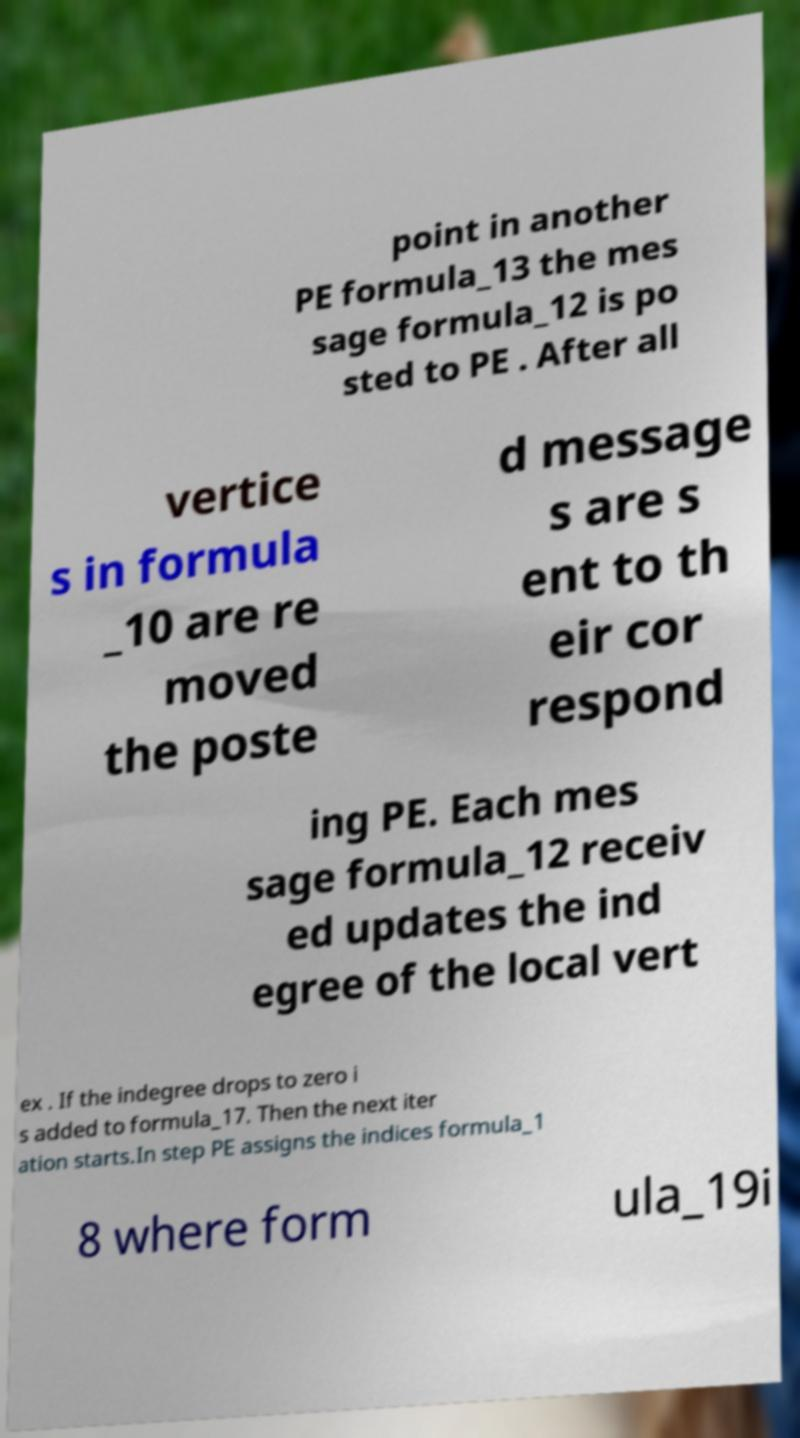Please identify and transcribe the text found in this image. point in another PE formula_13 the mes sage formula_12 is po sted to PE . After all vertice s in formula _10 are re moved the poste d message s are s ent to th eir cor respond ing PE. Each mes sage formula_12 receiv ed updates the ind egree of the local vert ex . If the indegree drops to zero i s added to formula_17. Then the next iter ation starts.In step PE assigns the indices formula_1 8 where form ula_19i 